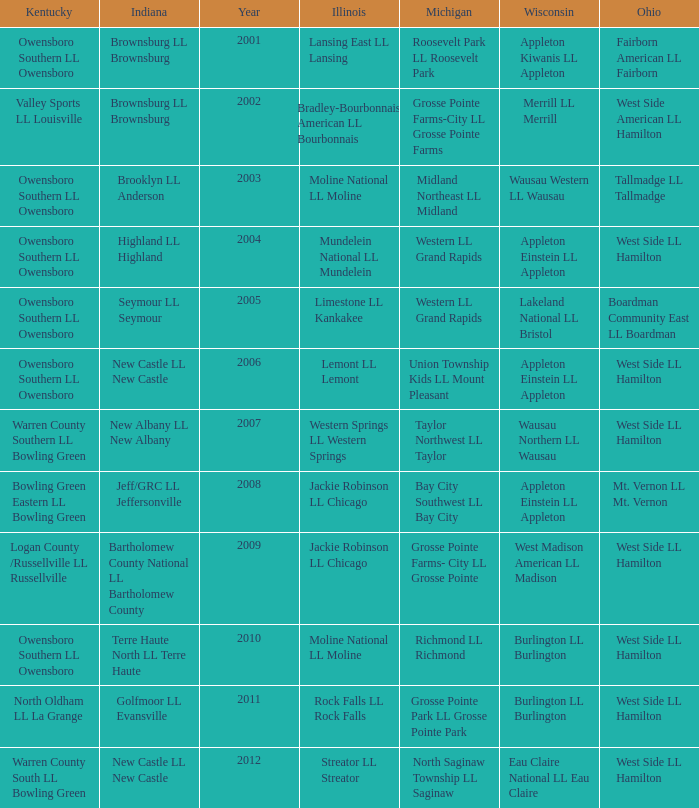What was the little league team from Ohio when the little league team from Kentucky was Warren County South LL Bowling Green? West Side LL Hamilton. 